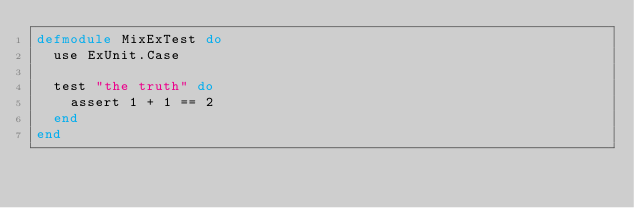Convert code to text. <code><loc_0><loc_0><loc_500><loc_500><_Elixir_>defmodule MixExTest do
  use ExUnit.Case

  test "the truth" do
    assert 1 + 1 == 2
  end
end
</code> 